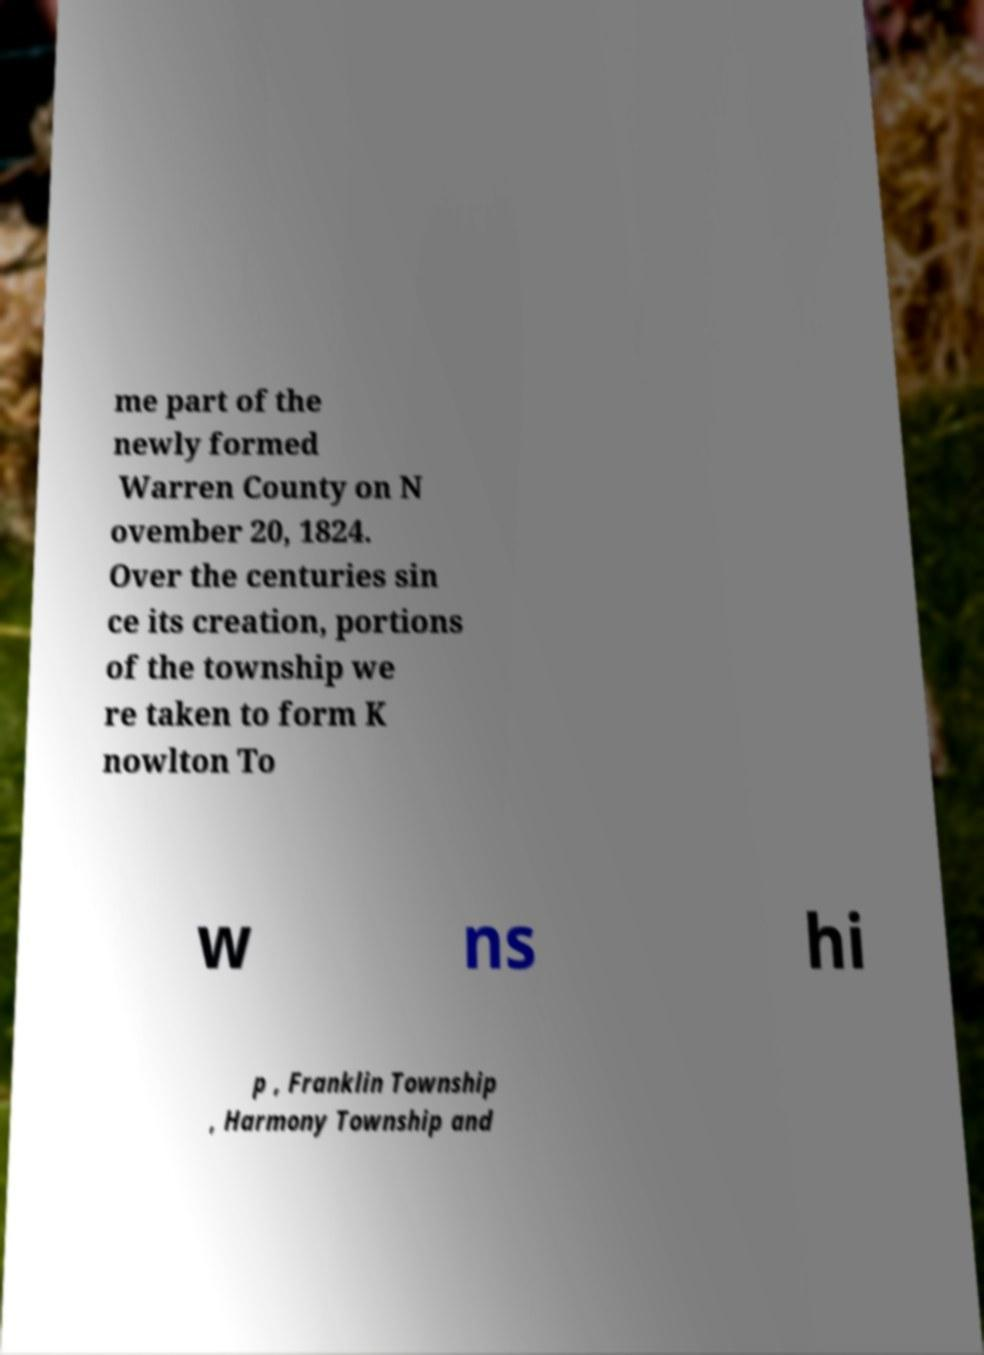I need the written content from this picture converted into text. Can you do that? me part of the newly formed Warren County on N ovember 20, 1824. Over the centuries sin ce its creation, portions of the township we re taken to form K nowlton To w ns hi p , Franklin Township , Harmony Township and 